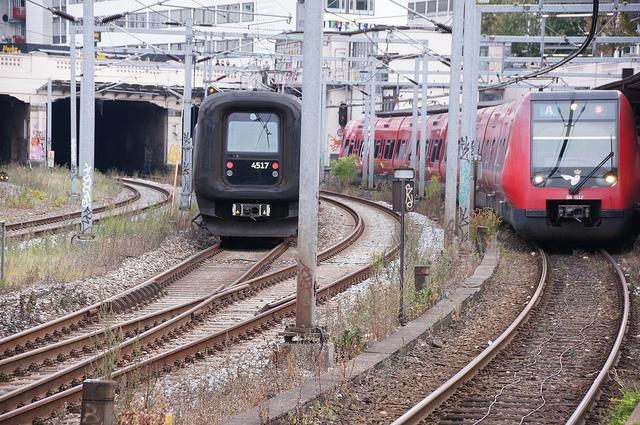The trains have what safety feature on the glass to help see visibly in stormy weather?

Choices:
A) turning signals
B) windshield wipers
C) high beams
D) fog heater windshield wipers 